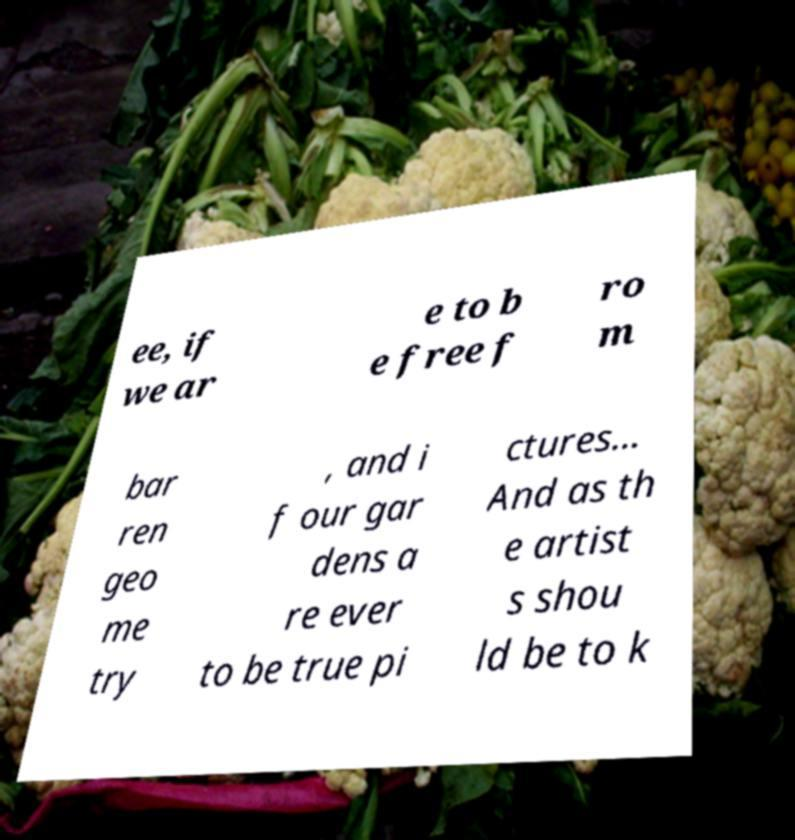Can you read and provide the text displayed in the image?This photo seems to have some interesting text. Can you extract and type it out for me? ee, if we ar e to b e free f ro m bar ren geo me try , and i f our gar dens a re ever to be true pi ctures... And as th e artist s shou ld be to k 